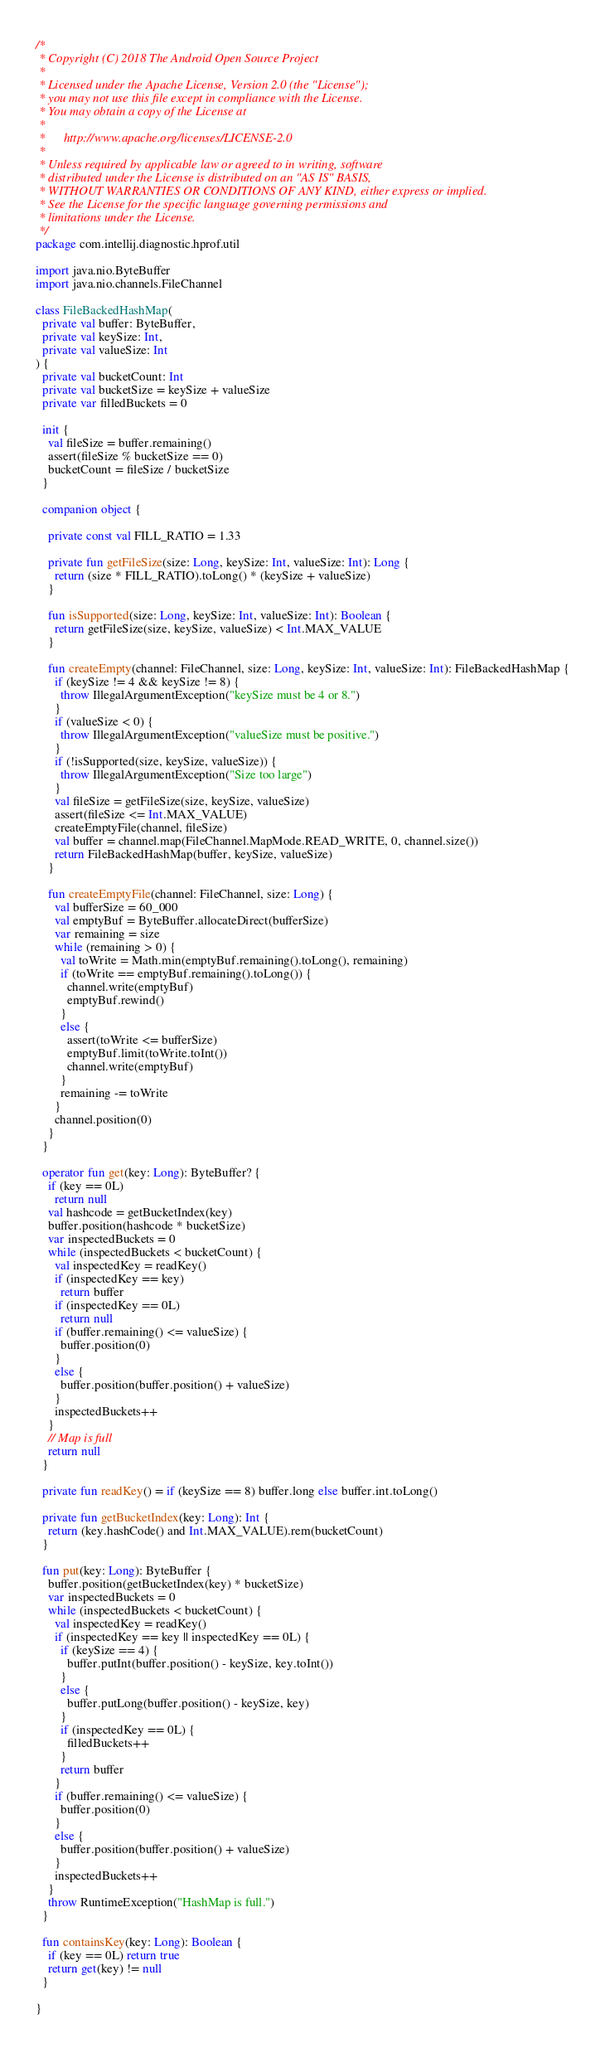Convert code to text. <code><loc_0><loc_0><loc_500><loc_500><_Kotlin_>/*
 * Copyright (C) 2018 The Android Open Source Project
 *
 * Licensed under the Apache License, Version 2.0 (the "License");
 * you may not use this file except in compliance with the License.
 * You may obtain a copy of the License at
 *
 *      http://www.apache.org/licenses/LICENSE-2.0
 *
 * Unless required by applicable law or agreed to in writing, software
 * distributed under the License is distributed on an "AS IS" BASIS,
 * WITHOUT WARRANTIES OR CONDITIONS OF ANY KIND, either express or implied.
 * See the License for the specific language governing permissions and
 * limitations under the License.
 */
package com.intellij.diagnostic.hprof.util

import java.nio.ByteBuffer
import java.nio.channels.FileChannel

class FileBackedHashMap(
  private val buffer: ByteBuffer,
  private val keySize: Int,
  private val valueSize: Int
) {
  private val bucketCount: Int
  private val bucketSize = keySize + valueSize
  private var filledBuckets = 0

  init {
    val fileSize = buffer.remaining()
    assert(fileSize % bucketSize == 0)
    bucketCount = fileSize / bucketSize
  }

  companion object {

    private const val FILL_RATIO = 1.33

    private fun getFileSize(size: Long, keySize: Int, valueSize: Int): Long {
      return (size * FILL_RATIO).toLong() * (keySize + valueSize)
    }

    fun isSupported(size: Long, keySize: Int, valueSize: Int): Boolean {
      return getFileSize(size, keySize, valueSize) < Int.MAX_VALUE
    }

    fun createEmpty(channel: FileChannel, size: Long, keySize: Int, valueSize: Int): FileBackedHashMap {
      if (keySize != 4 && keySize != 8) {
        throw IllegalArgumentException("keySize must be 4 or 8.")
      }
      if (valueSize < 0) {
        throw IllegalArgumentException("valueSize must be positive.")
      }
      if (!isSupported(size, keySize, valueSize)) {
        throw IllegalArgumentException("Size too large")
      }
      val fileSize = getFileSize(size, keySize, valueSize)
      assert(fileSize <= Int.MAX_VALUE)
      createEmptyFile(channel, fileSize)
      val buffer = channel.map(FileChannel.MapMode.READ_WRITE, 0, channel.size())
      return FileBackedHashMap(buffer, keySize, valueSize)
    }

    fun createEmptyFile(channel: FileChannel, size: Long) {
      val bufferSize = 60_000
      val emptyBuf = ByteBuffer.allocateDirect(bufferSize)
      var remaining = size
      while (remaining > 0) {
        val toWrite = Math.min(emptyBuf.remaining().toLong(), remaining)
        if (toWrite == emptyBuf.remaining().toLong()) {
          channel.write(emptyBuf)
          emptyBuf.rewind()
        }
        else {
          assert(toWrite <= bufferSize)
          emptyBuf.limit(toWrite.toInt())
          channel.write(emptyBuf)
        }
        remaining -= toWrite
      }
      channel.position(0)
    }
  }

  operator fun get(key: Long): ByteBuffer? {
    if (key == 0L)
      return null
    val hashcode = getBucketIndex(key)
    buffer.position(hashcode * bucketSize)
    var inspectedBuckets = 0
    while (inspectedBuckets < bucketCount) {
      val inspectedKey = readKey()
      if (inspectedKey == key)
        return buffer
      if (inspectedKey == 0L)
        return null
      if (buffer.remaining() <= valueSize) {
        buffer.position(0)
      }
      else {
        buffer.position(buffer.position() + valueSize)
      }
      inspectedBuckets++
    }
    // Map is full
    return null
  }

  private fun readKey() = if (keySize == 8) buffer.long else buffer.int.toLong()

  private fun getBucketIndex(key: Long): Int {
    return (key.hashCode() and Int.MAX_VALUE).rem(bucketCount)
  }

  fun put(key: Long): ByteBuffer {
    buffer.position(getBucketIndex(key) * bucketSize)
    var inspectedBuckets = 0
    while (inspectedBuckets < bucketCount) {
      val inspectedKey = readKey()
      if (inspectedKey == key || inspectedKey == 0L) {
        if (keySize == 4) {
          buffer.putInt(buffer.position() - keySize, key.toInt())
        }
        else {
          buffer.putLong(buffer.position() - keySize, key)
        }
        if (inspectedKey == 0L) {
          filledBuckets++
        }
        return buffer
      }
      if (buffer.remaining() <= valueSize) {
        buffer.position(0)
      }
      else {
        buffer.position(buffer.position() + valueSize)
      }
      inspectedBuckets++
    }
    throw RuntimeException("HashMap is full.")
  }

  fun containsKey(key: Long): Boolean {
    if (key == 0L) return true
    return get(key) != null
  }

}</code> 